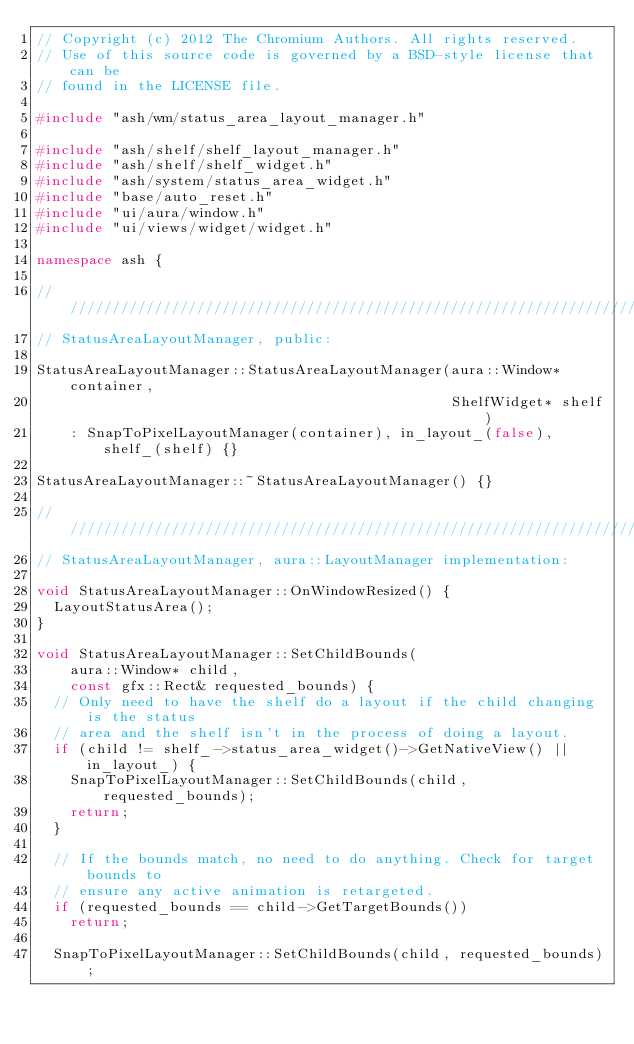Convert code to text. <code><loc_0><loc_0><loc_500><loc_500><_C++_>// Copyright (c) 2012 The Chromium Authors. All rights reserved.
// Use of this source code is governed by a BSD-style license that can be
// found in the LICENSE file.

#include "ash/wm/status_area_layout_manager.h"

#include "ash/shelf/shelf_layout_manager.h"
#include "ash/shelf/shelf_widget.h"
#include "ash/system/status_area_widget.h"
#include "base/auto_reset.h"
#include "ui/aura/window.h"
#include "ui/views/widget/widget.h"

namespace ash {

////////////////////////////////////////////////////////////////////////////////
// StatusAreaLayoutManager, public:

StatusAreaLayoutManager::StatusAreaLayoutManager(aura::Window* container,
                                                 ShelfWidget* shelf)
    : SnapToPixelLayoutManager(container), in_layout_(false), shelf_(shelf) {}

StatusAreaLayoutManager::~StatusAreaLayoutManager() {}

////////////////////////////////////////////////////////////////////////////////
// StatusAreaLayoutManager, aura::LayoutManager implementation:

void StatusAreaLayoutManager::OnWindowResized() {
  LayoutStatusArea();
}

void StatusAreaLayoutManager::SetChildBounds(
    aura::Window* child,
    const gfx::Rect& requested_bounds) {
  // Only need to have the shelf do a layout if the child changing is the status
  // area and the shelf isn't in the process of doing a layout.
  if (child != shelf_->status_area_widget()->GetNativeView() || in_layout_) {
    SnapToPixelLayoutManager::SetChildBounds(child, requested_bounds);
    return;
  }

  // If the bounds match, no need to do anything. Check for target bounds to
  // ensure any active animation is retargeted.
  if (requested_bounds == child->GetTargetBounds())
    return;

  SnapToPixelLayoutManager::SetChildBounds(child, requested_bounds);</code> 